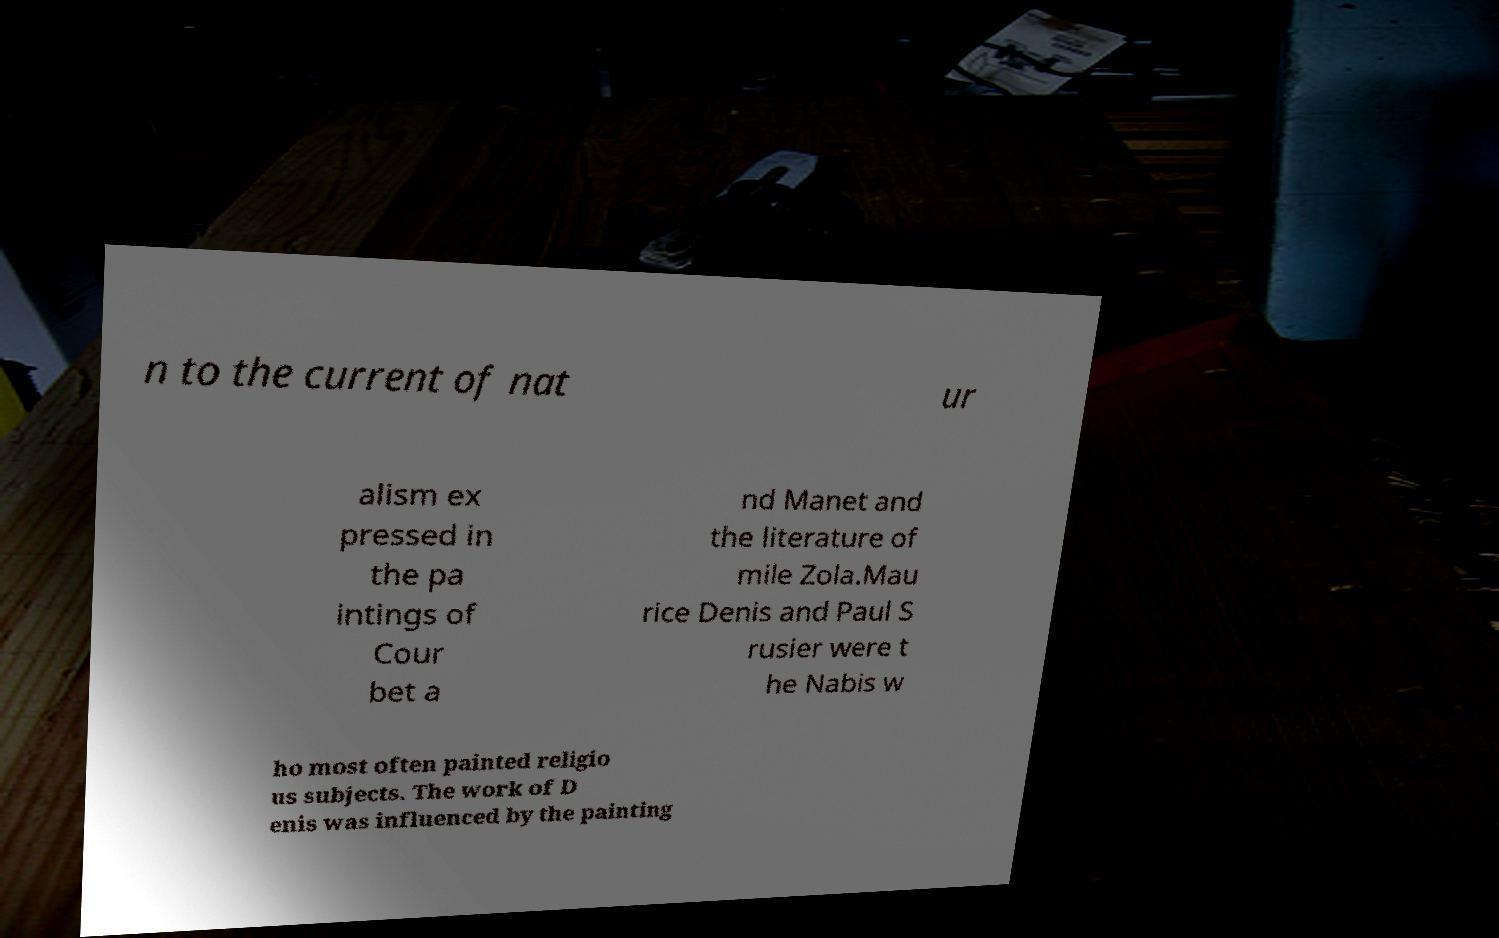There's text embedded in this image that I need extracted. Can you transcribe it verbatim? n to the current of nat ur alism ex pressed in the pa intings of Cour bet a nd Manet and the literature of mile Zola.Mau rice Denis and Paul S rusier were t he Nabis w ho most often painted religio us subjects. The work of D enis was influenced by the painting 